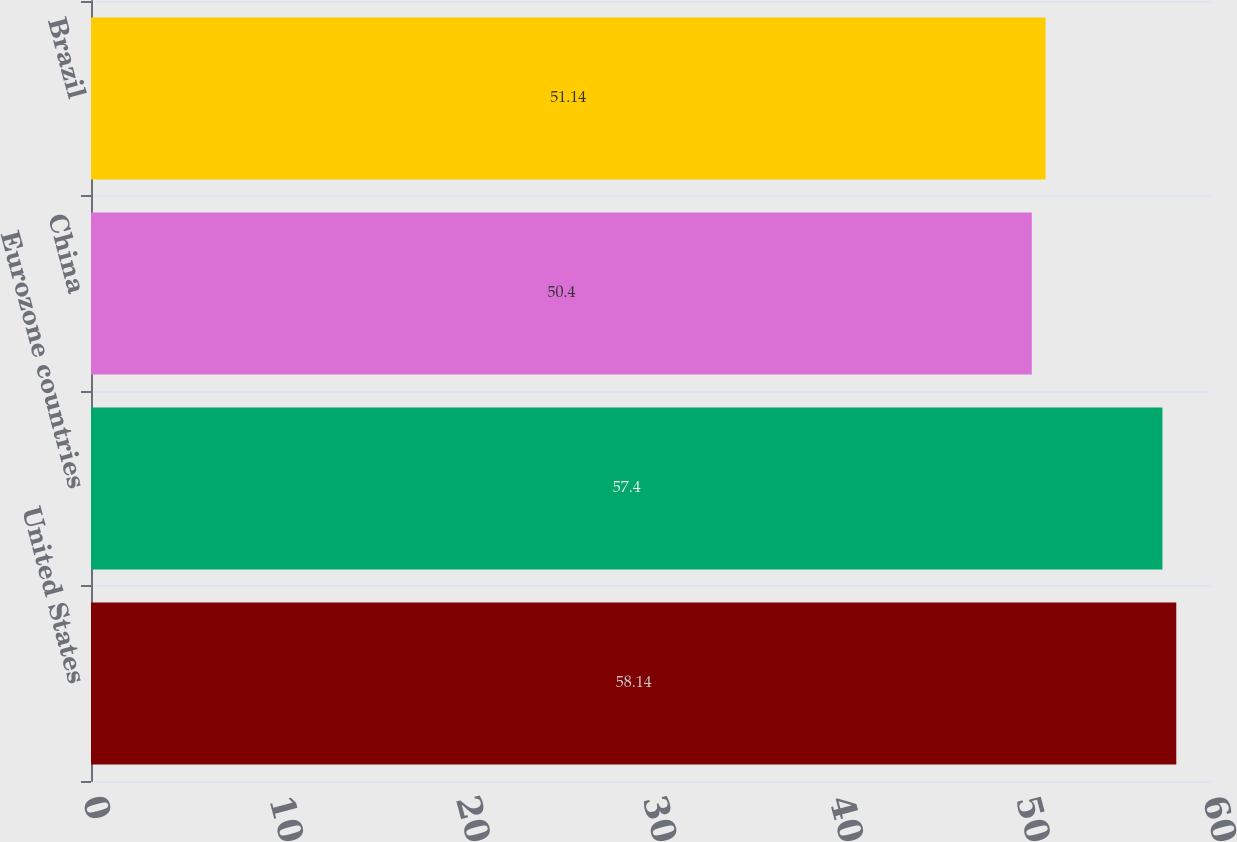<chart> <loc_0><loc_0><loc_500><loc_500><bar_chart><fcel>United States<fcel>Eurozone countries<fcel>China<fcel>Brazil<nl><fcel>58.14<fcel>57.4<fcel>50.4<fcel>51.14<nl></chart> 